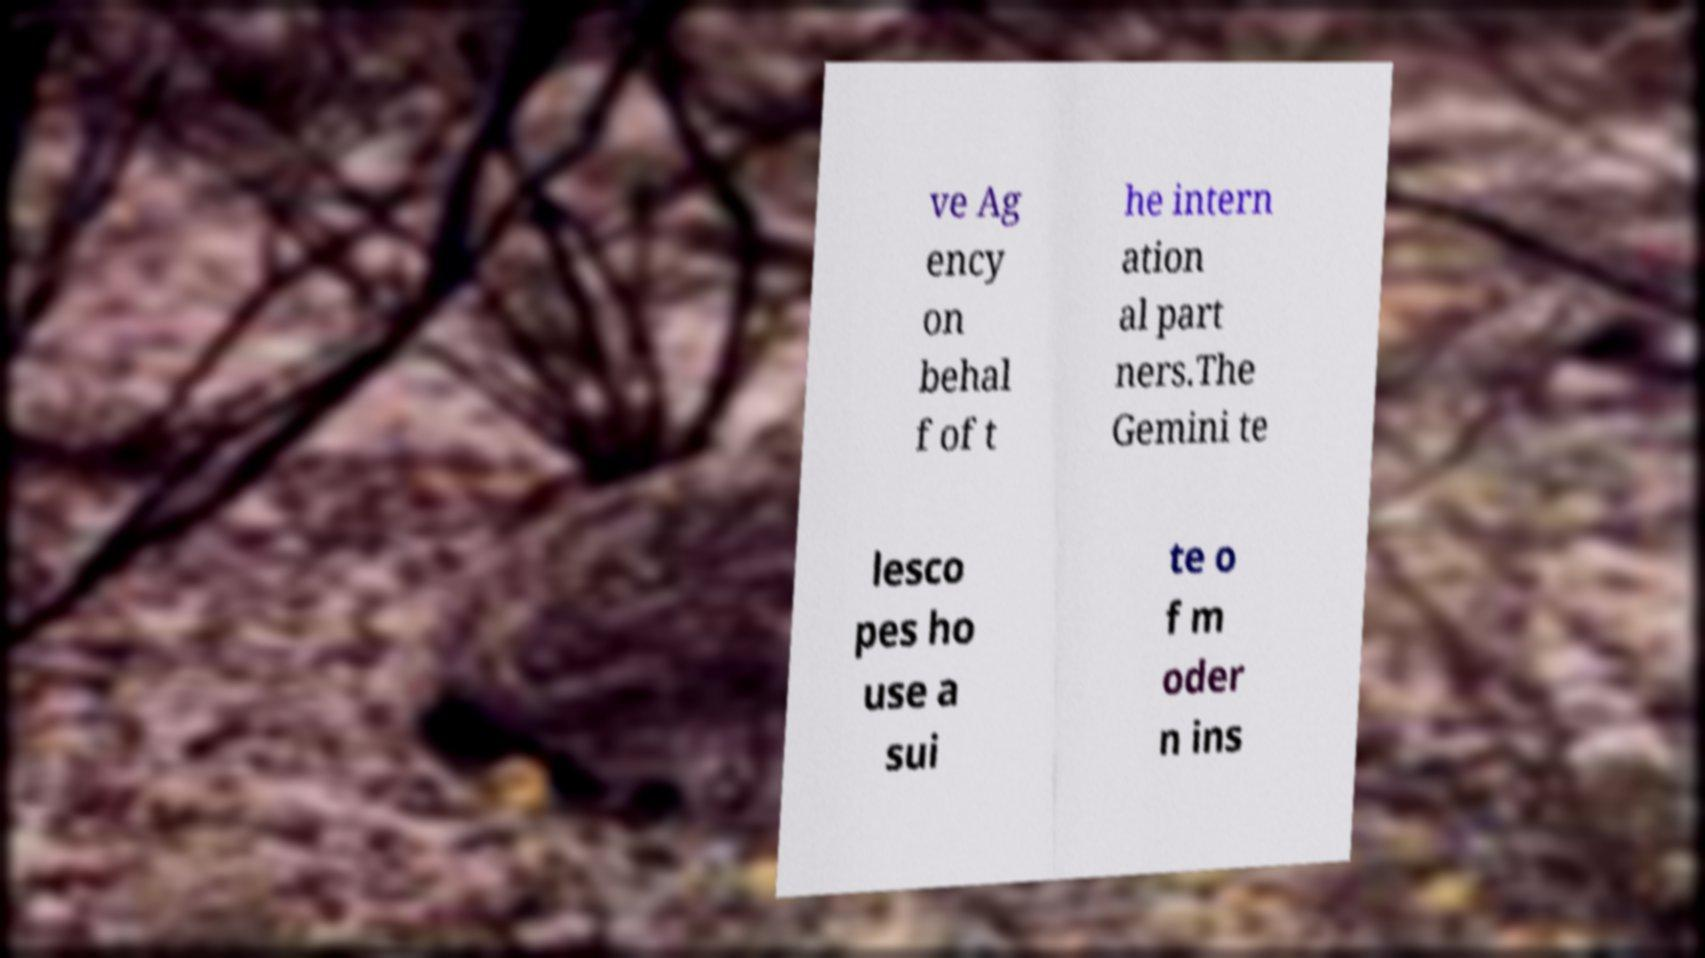Can you read and provide the text displayed in the image?This photo seems to have some interesting text. Can you extract and type it out for me? ve Ag ency on behal f of t he intern ation al part ners.The Gemini te lesco pes ho use a sui te o f m oder n ins 